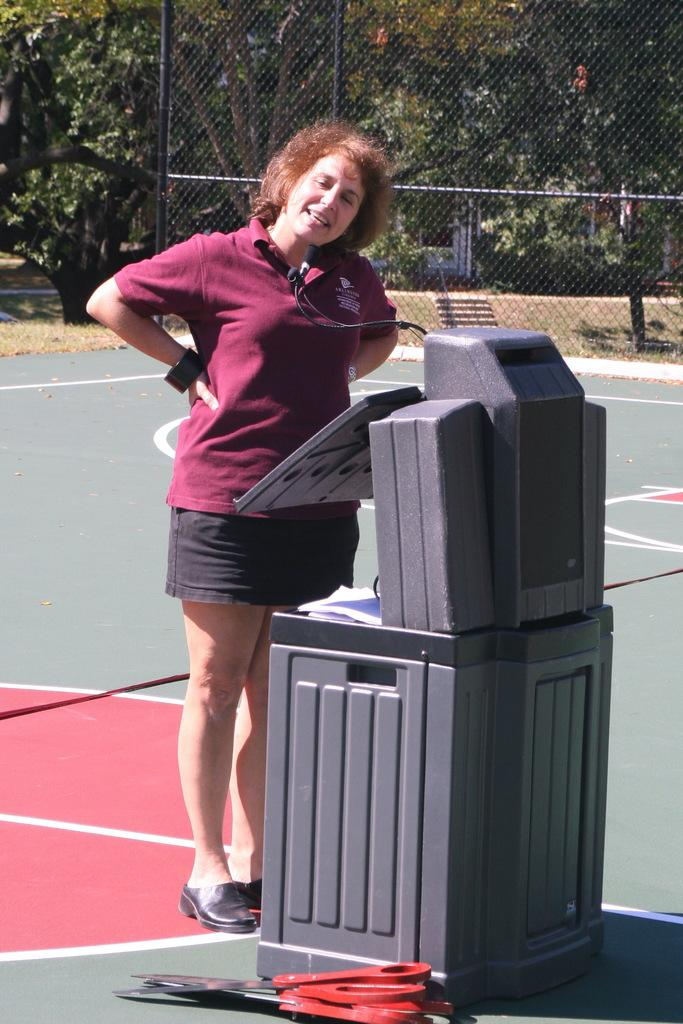What is the main subject of the image? There is a woman standing in the image. What is the woman standing on? The woman is standing on the ground. What object can be seen in the image? Scissors are visible in the image. What can be seen in the background of the image? There is a fence and trees in the background of the image. What type of berry is the woman holding in the image? There is no berry present in the image; the woman is not holding anything. What is the woman's opinion on the fence in the background? The image does not provide any information about the woman's opinion on the fence in the background. 